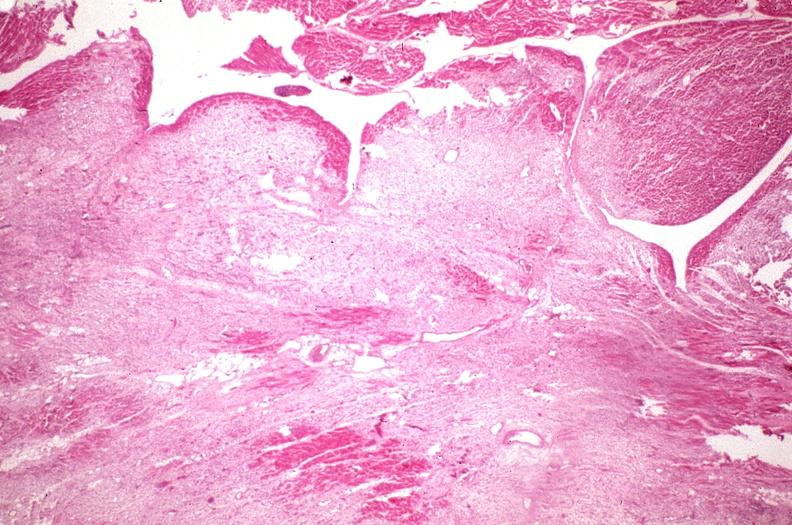does this image show heart, fibrosis, chronic rheumatic heart disease?
Answer the question using a single word or phrase. Yes 